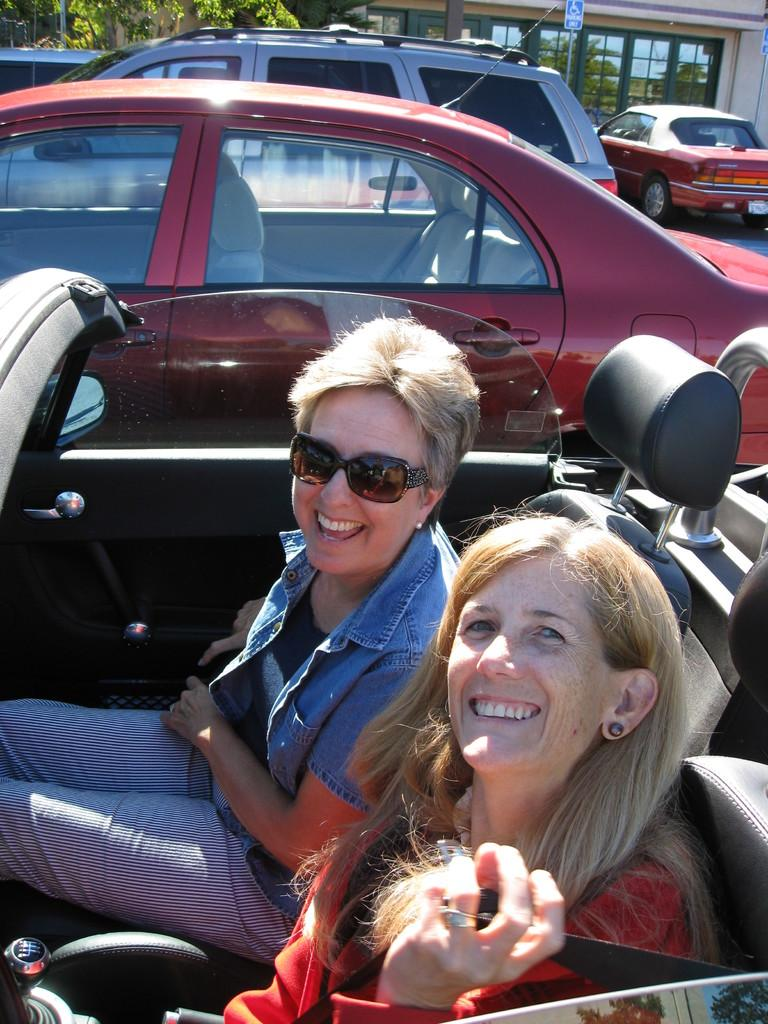How many women are in the image? There are two women in the image. What are the women doing in the image? The women are sitting in a car and smiling. What can be seen in the background of the image? There are vehicles, a building, and a tree in the background of the image. What type of discovery did the women make while riding the horse in the image? There is no horse present in the image, and therefore no discovery can be made while riding one. 